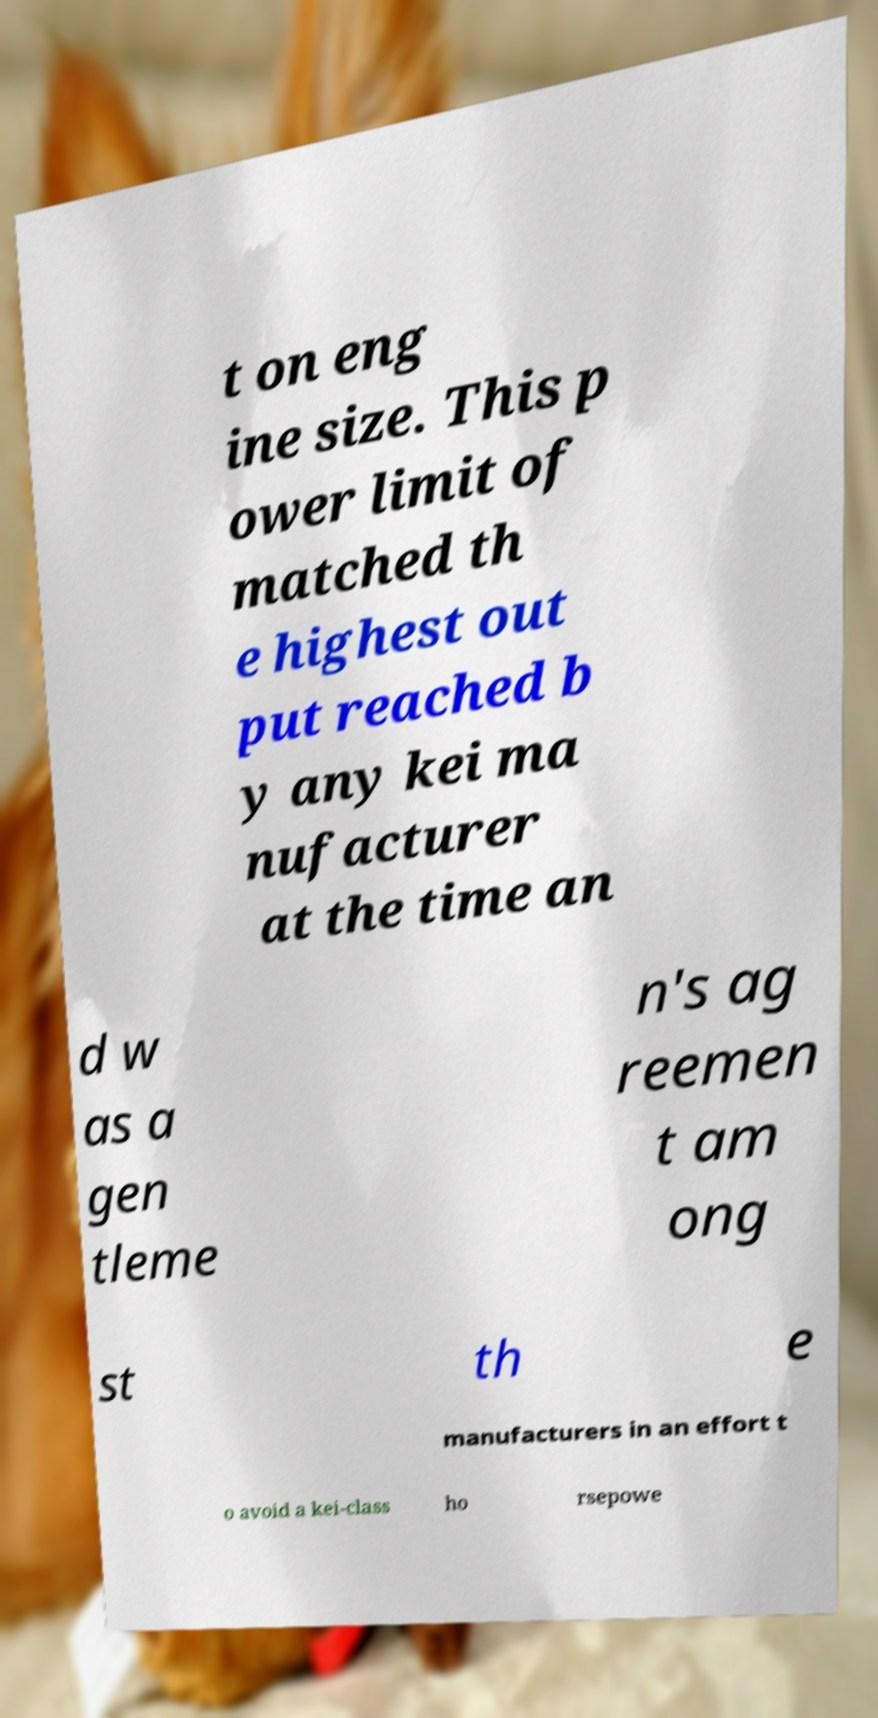What messages or text are displayed in this image? I need them in a readable, typed format. t on eng ine size. This p ower limit of matched th e highest out put reached b y any kei ma nufacturer at the time an d w as a gen tleme n's ag reemen t am ong st th e manufacturers in an effort t o avoid a kei-class ho rsepowe 